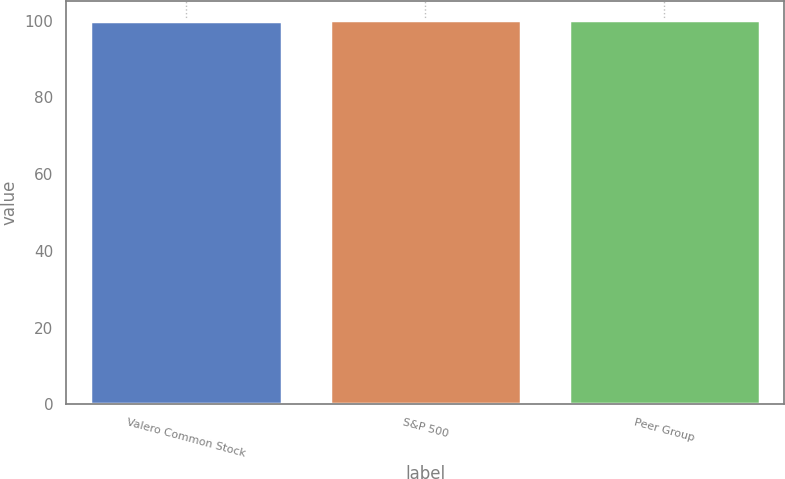Convert chart. <chart><loc_0><loc_0><loc_500><loc_500><bar_chart><fcel>Valero Common Stock<fcel>S&P 500<fcel>Peer Group<nl><fcel>100<fcel>100.1<fcel>100.2<nl></chart> 